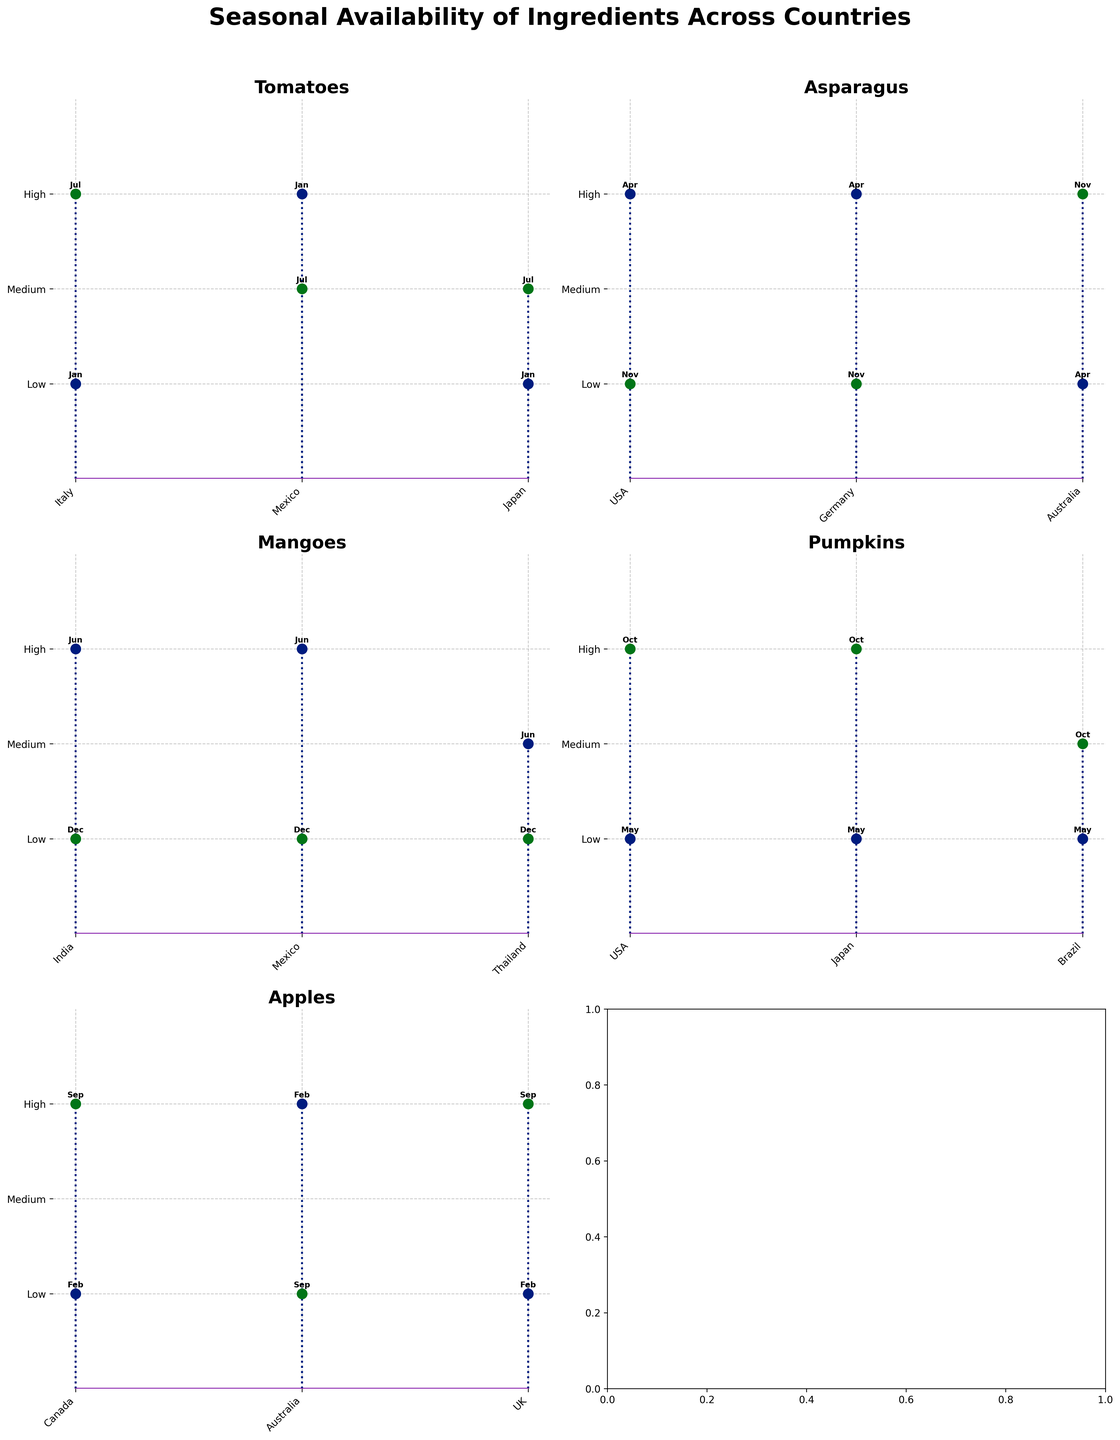What ingredient has the highest availability in Japan in October? Looking at the plot for Pumpkins, we can see that the availability in Japan in October is labeled as "High".
Answer: Pumpkins Which country has the highest tomato availability in January? The plot for Tomatoes shows Mexico having a "High" availability in January, compared to Italy and Japan both having "Low" availability for the same month.
Answer: Mexico In which months do Germany and USA have the same level of asparagus availability? We examine the plot for Asparagus and look for months where the availability markers are at the same value for Germany and USA. Both countries show "High" availability in April and "Low" in November.
Answer: April, November Compare the availability of mangoes in June across India, Mexico, and Thailand. By looking at the Mangoes plot, India and Mexico have "High" availability in June, while Thailand has "Medium" availability. This shows that India and Mexico have greater availability than Thailand in June.
Answer: India and Mexico are higher In which month does Australia have the highest availability of apples? For the plot showing Apples, we see that Australia's availability is "High" in February. In September, the availability is "Low". Therefore, the highest availability is in February.
Answer: February What is the general trend of pumpkin availability across all countries, from May to October? Observing the Pumpkins plot, availability across USA, Japan, and Brazil is low in May and becomes high or medium in October, indicating a trend of increasing availability from May to October.
Answer: Increasing from May to October Which country has the most consistently high availability of asparagus throughout the months shown? The plot for Asparagus shows that both the USA and Germany have "High" availability in April but "Low" in November. Australia has contrasting values with "Low" in April and "High" in November. None of the countries show consistently high availability throughout.
Answer: None How does the availability of tomatoes in Italy compare between January and July? In the Tomatoes plot, Italy shows "High" availability in July and "Low" availability in January, indicating a significant seasonal difference.
Answer: Higher in July than January What are the similarities in apple availability between Canada and the UK in the shown months? Both the plots for Apple show "High" availability in September and "Low" availability in February for Canada and the UK, indicating similar seasonal trends.
Answer: Both High in September and Low in February Among all countries, which ingredient shows the most variation in availability across different months? Looking across all plots, Tomatoes show different availability spanning "Low", "Medium", and "High" across different months and countries, indicating the highest variation.
Answer: Tomatoes 